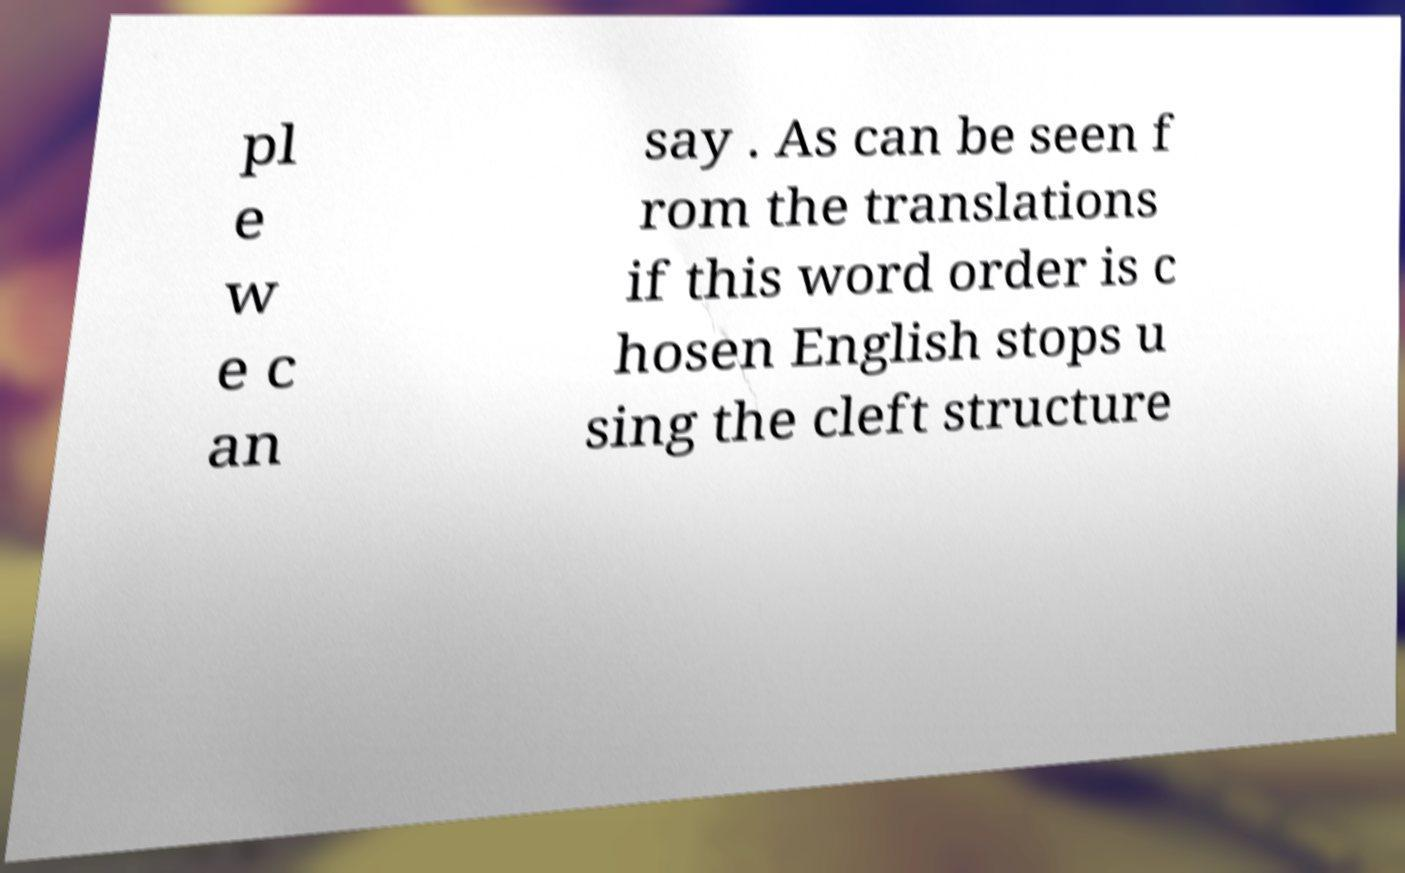Can you read and provide the text displayed in the image?This photo seems to have some interesting text. Can you extract and type it out for me? pl e w e c an say . As can be seen f rom the translations if this word order is c hosen English stops u sing the cleft structure 